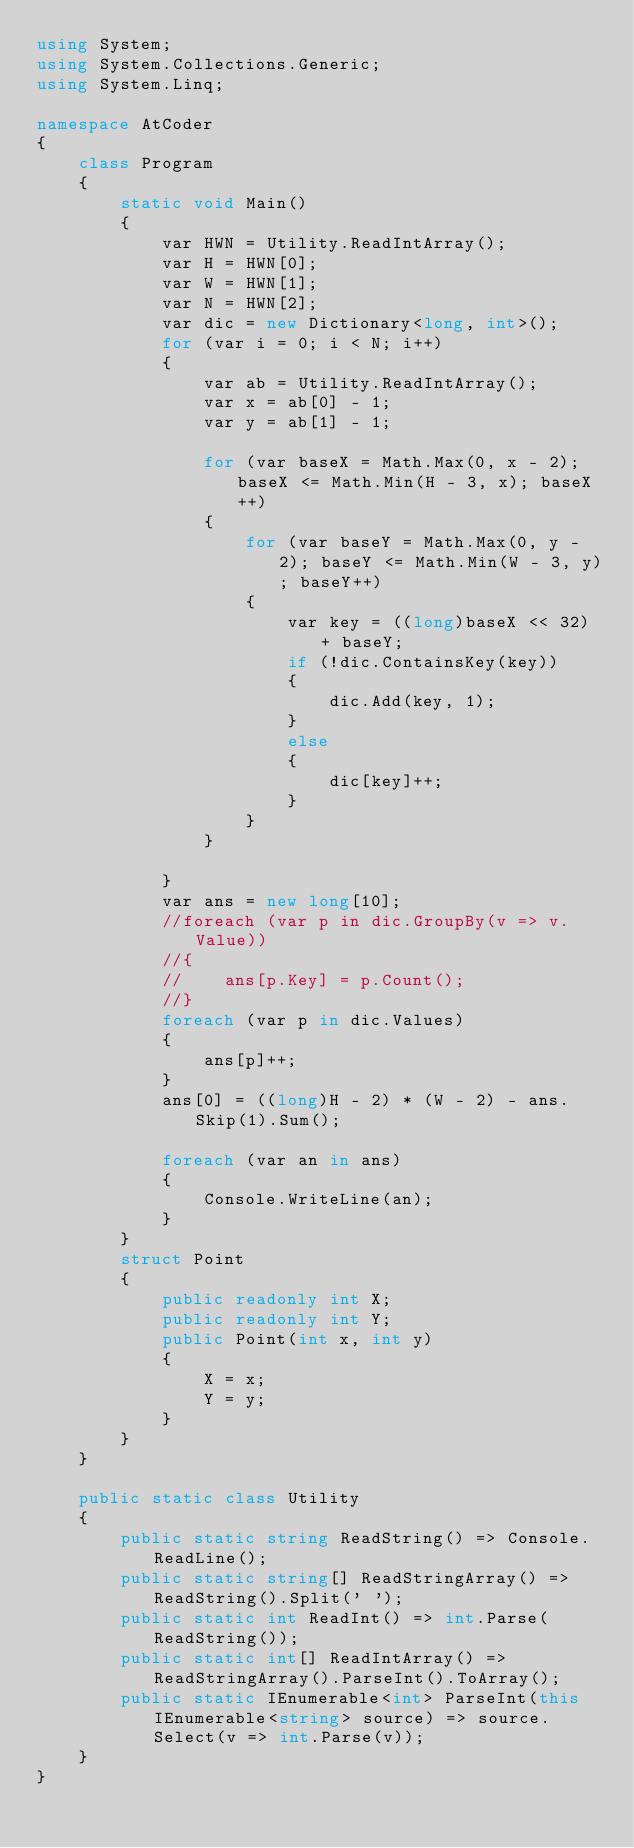Convert code to text. <code><loc_0><loc_0><loc_500><loc_500><_C#_>using System;
using System.Collections.Generic;
using System.Linq;

namespace AtCoder
{
    class Program
    {
        static void Main()
        {
            var HWN = Utility.ReadIntArray();
            var H = HWN[0];
            var W = HWN[1];
            var N = HWN[2];
            var dic = new Dictionary<long, int>();
            for (var i = 0; i < N; i++)
            {
                var ab = Utility.ReadIntArray();
                var x = ab[0] - 1;
                var y = ab[1] - 1;

                for (var baseX = Math.Max(0, x - 2); baseX <= Math.Min(H - 3, x); baseX++)
                {
                    for (var baseY = Math.Max(0, y - 2); baseY <= Math.Min(W - 3, y); baseY++)
                    {
                        var key = ((long)baseX << 32) + baseY;
                        if (!dic.ContainsKey(key))
                        {
                            dic.Add(key, 1);
                        }
                        else
                        {
                            dic[key]++;
                        }
                    }
                }

            }
            var ans = new long[10];
            //foreach (var p in dic.GroupBy(v => v.Value))
            //{
            //    ans[p.Key] = p.Count();
            //}
            foreach (var p in dic.Values)
            {
                ans[p]++;
            }
            ans[0] = ((long)H - 2) * (W - 2) - ans.Skip(1).Sum();

            foreach (var an in ans)
            {
                Console.WriteLine(an);
            }
        }
        struct Point
        {
            public readonly int X;
            public readonly int Y;
            public Point(int x, int y)
            {
                X = x;
                Y = y;
            }
        }
    }

    public static class Utility
    {
        public static string ReadString() => Console.ReadLine();
        public static string[] ReadStringArray() => ReadString().Split(' ');
        public static int ReadInt() => int.Parse(ReadString());
        public static int[] ReadIntArray() => ReadStringArray().ParseInt().ToArray();
        public static IEnumerable<int> ParseInt(this IEnumerable<string> source) => source.Select(v => int.Parse(v));
    }
}
</code> 